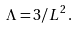<formula> <loc_0><loc_0><loc_500><loc_500>\Lambda = 3 / L ^ { 2 } \, .</formula> 